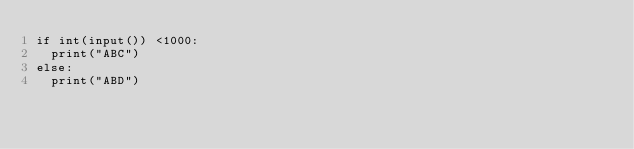Convert code to text. <code><loc_0><loc_0><loc_500><loc_500><_Python_>if int(input()) <1000:
  print("ABC")
else:
  print("ABD")</code> 